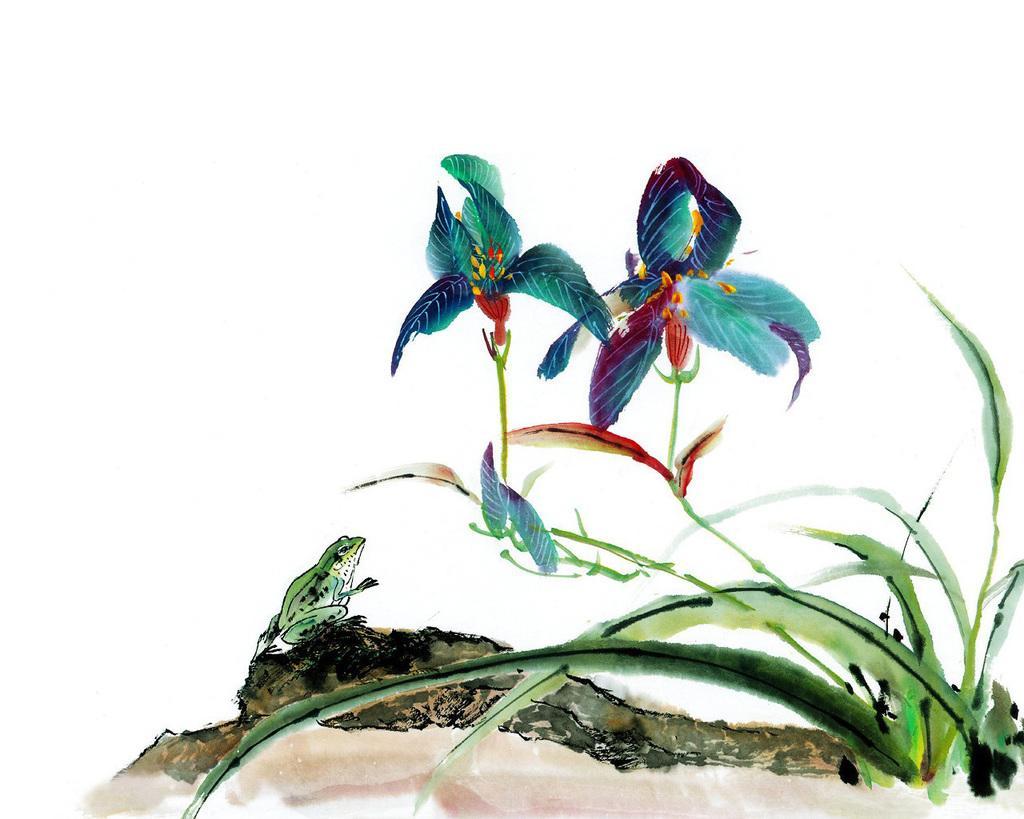Could you give a brief overview of what you see in this image? This looks like a painting. These are the plants with the flowers. I can see a frog sitting on a rock. 